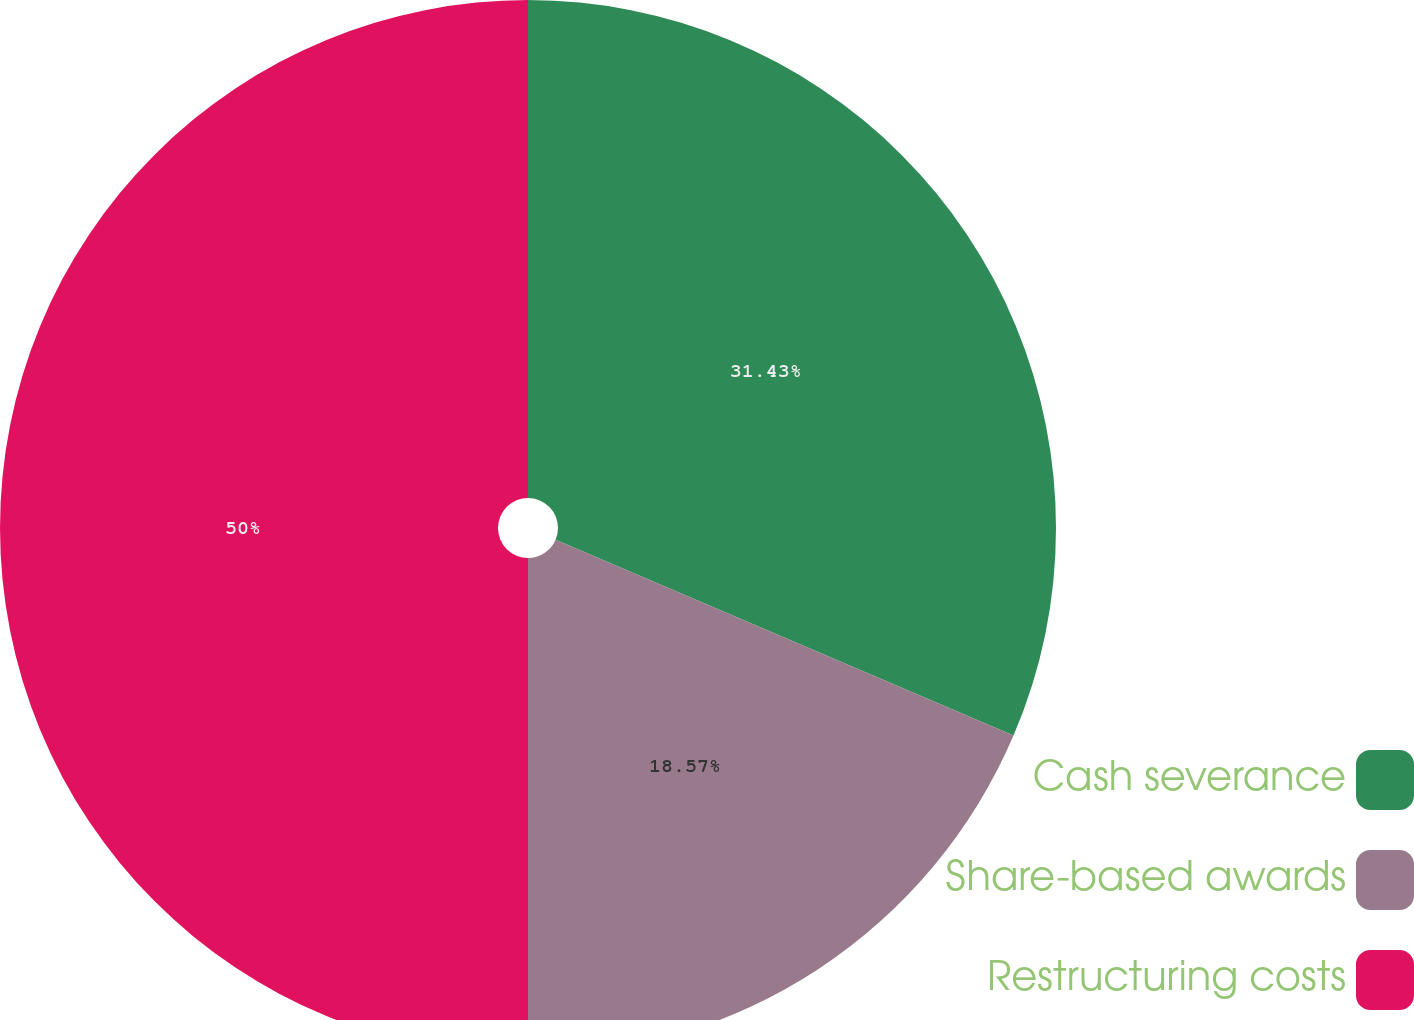Convert chart to OTSL. <chart><loc_0><loc_0><loc_500><loc_500><pie_chart><fcel>Cash severance<fcel>Share-based awards<fcel>Restructuring costs<nl><fcel>31.43%<fcel>18.57%<fcel>50.0%<nl></chart> 